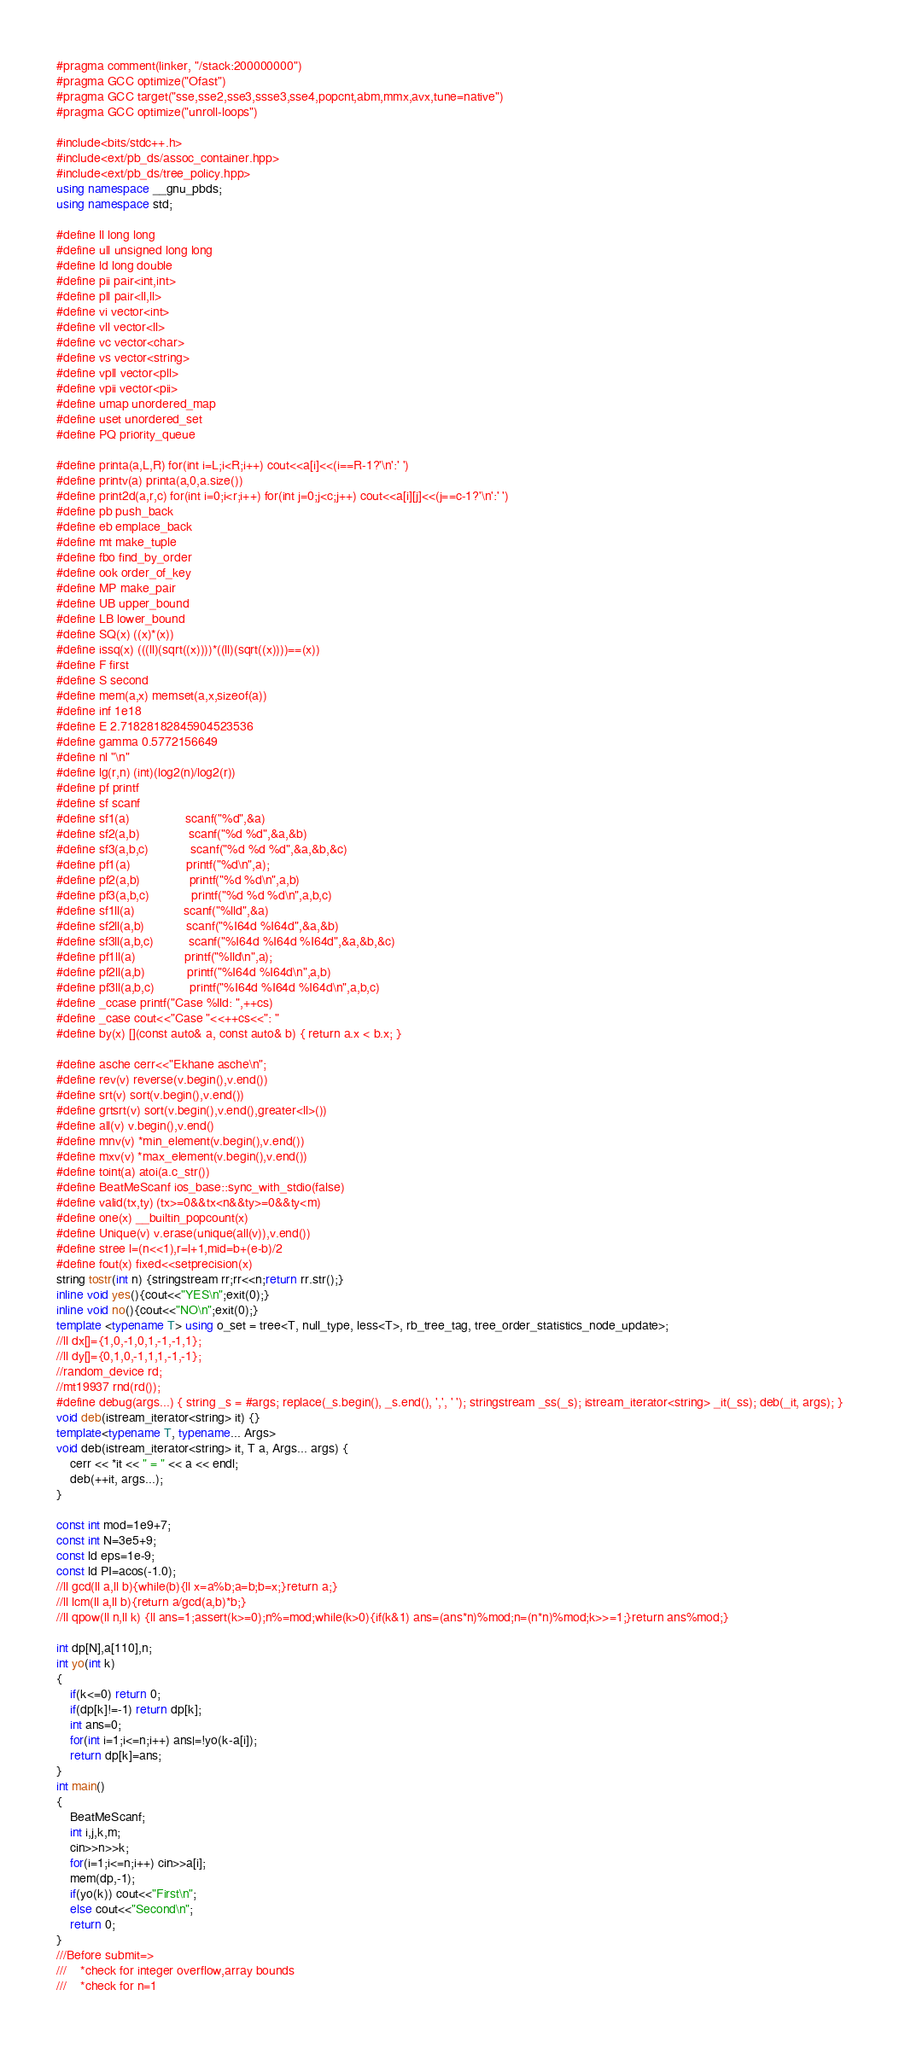<code> <loc_0><loc_0><loc_500><loc_500><_C++_>#pragma comment(linker, "/stack:200000000")
#pragma GCC optimize("Ofast")
#pragma GCC target("sse,sse2,sse3,ssse3,sse4,popcnt,abm,mmx,avx,tune=native")
#pragma GCC optimize("unroll-loops")

#include<bits/stdc++.h>
#include<ext/pb_ds/assoc_container.hpp>
#include<ext/pb_ds/tree_policy.hpp>
using namespace __gnu_pbds;
using namespace std;

#define ll long long
#define ull unsigned long long
#define ld long double
#define pii pair<int,int>
#define pll pair<ll,ll>
#define vi vector<int>
#define vll vector<ll>
#define vc vector<char>
#define vs vector<string>
#define vpll vector<pll>
#define vpii vector<pii>
#define umap unordered_map
#define uset unordered_set
#define PQ priority_queue

#define printa(a,L,R) for(int i=L;i<R;i++) cout<<a[i]<<(i==R-1?'\n':' ')
#define printv(a) printa(a,0,a.size())
#define print2d(a,r,c) for(int i=0;i<r;i++) for(int j=0;j<c;j++) cout<<a[i][j]<<(j==c-1?'\n':' ')
#define pb push_back
#define eb emplace_back
#define mt make_tuple
#define fbo find_by_order
#define ook order_of_key
#define MP make_pair
#define UB upper_bound
#define LB lower_bound
#define SQ(x) ((x)*(x))
#define issq(x) (((ll)(sqrt((x))))*((ll)(sqrt((x))))==(x))
#define F first
#define S second
#define mem(a,x) memset(a,x,sizeof(a))
#define inf 1e18
#define E 2.71828182845904523536
#define gamma 0.5772156649
#define nl "\n"
#define lg(r,n) (int)(log2(n)/log2(r))
#define pf printf
#define sf scanf
#define sf1(a)                scanf("%d",&a)
#define sf2(a,b)              scanf("%d %d",&a,&b)
#define sf3(a,b,c)            scanf("%d %d %d",&a,&b,&c)
#define pf1(a)                printf("%d\n",a);
#define pf2(a,b)              printf("%d %d\n",a,b)
#define pf3(a,b,c)            printf("%d %d %d\n",a,b,c)
#define sf1ll(a)              scanf("%lld",&a)
#define sf2ll(a,b)            scanf("%I64d %I64d",&a,&b)
#define sf3ll(a,b,c)          scanf("%I64d %I64d %I64d",&a,&b,&c)
#define pf1ll(a)              printf("%lld\n",a);
#define pf2ll(a,b)            printf("%I64d %I64d\n",a,b)
#define pf3ll(a,b,c)          printf("%I64d %I64d %I64d\n",a,b,c)
#define _ccase printf("Case %lld: ",++cs)
#define _case cout<<"Case "<<++cs<<": "
#define by(x) [](const auto& a, const auto& b) { return a.x < b.x; }

#define asche cerr<<"Ekhane asche\n";
#define rev(v) reverse(v.begin(),v.end())
#define srt(v) sort(v.begin(),v.end())
#define grtsrt(v) sort(v.begin(),v.end(),greater<ll>())
#define all(v) v.begin(),v.end()
#define mnv(v) *min_element(v.begin(),v.end())
#define mxv(v) *max_element(v.begin(),v.end())
#define toint(a) atoi(a.c_str())
#define BeatMeScanf ios_base::sync_with_stdio(false)
#define valid(tx,ty) (tx>=0&&tx<n&&ty>=0&&ty<m)
#define one(x) __builtin_popcount(x)
#define Unique(v) v.erase(unique(all(v)),v.end())
#define stree l=(n<<1),r=l+1,mid=b+(e-b)/2
#define fout(x) fixed<<setprecision(x)
string tostr(int n) {stringstream rr;rr<<n;return rr.str();}
inline void yes(){cout<<"YES\n";exit(0);}
inline void no(){cout<<"NO\n";exit(0);}
template <typename T> using o_set = tree<T, null_type, less<T>, rb_tree_tag, tree_order_statistics_node_update>;
//ll dx[]={1,0,-1,0,1,-1,-1,1};
//ll dy[]={0,1,0,-1,1,1,-1,-1};
//random_device rd;
//mt19937 rnd(rd());
#define debug(args...) { string _s = #args; replace(_s.begin(), _s.end(), ',', ' '); stringstream _ss(_s); istream_iterator<string> _it(_ss); deb(_it, args); }
void deb(istream_iterator<string> it) {}
template<typename T, typename... Args>
void deb(istream_iterator<string> it, T a, Args... args) {
    cerr << *it << " = " << a << endl;
    deb(++it, args...);
}

const int mod=1e9+7;
const int N=3e5+9;
const ld eps=1e-9;
const ld PI=acos(-1.0);
//ll gcd(ll a,ll b){while(b){ll x=a%b;a=b;b=x;}return a;}
//ll lcm(ll a,ll b){return a/gcd(a,b)*b;}
//ll qpow(ll n,ll k) {ll ans=1;assert(k>=0);n%=mod;while(k>0){if(k&1) ans=(ans*n)%mod;n=(n*n)%mod;k>>=1;}return ans%mod;}

int dp[N],a[110],n;
int yo(int k)
{
    if(k<=0) return 0;
    if(dp[k]!=-1) return dp[k];
    int ans=0;
    for(int i=1;i<=n;i++) ans|=!yo(k-a[i]);
    return dp[k]=ans;
}
int main()
{
    BeatMeScanf;
    int i,j,k,m;
    cin>>n>>k;
    for(i=1;i<=n;i++) cin>>a[i];
    mem(dp,-1);
    if(yo(k)) cout<<"First\n";
    else cout<<"Second\n";
    return 0;
}
///Before submit=>
///    *check for integer overflow,array bounds
///    *check for n=1

</code> 